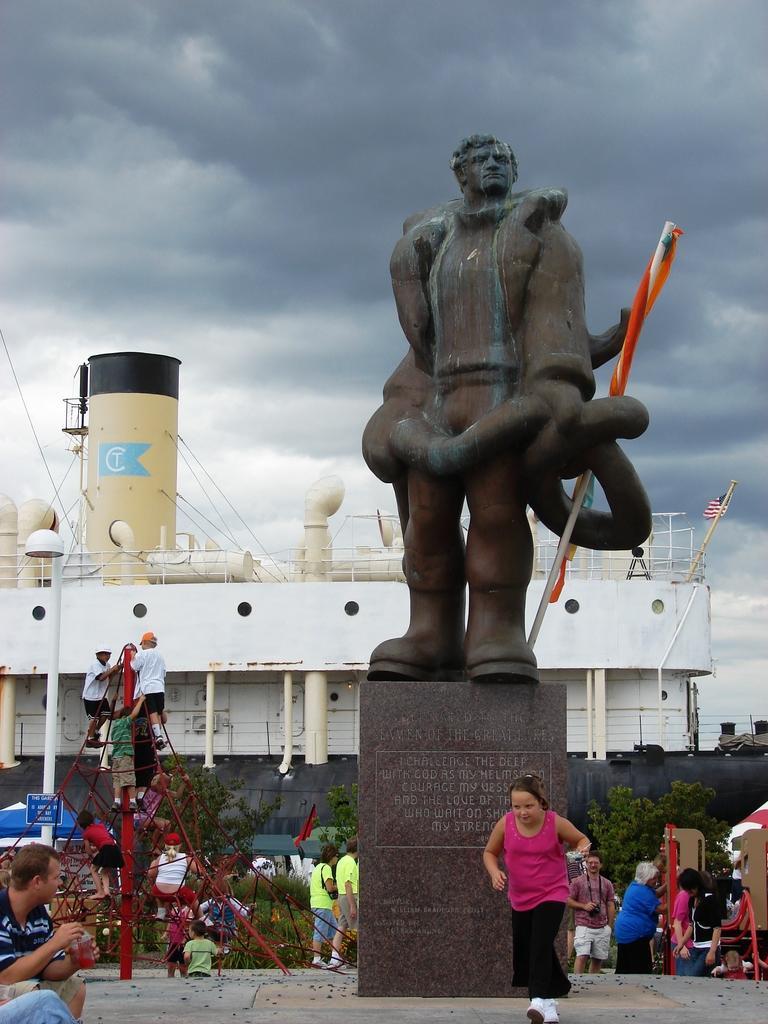Please provide a concise description of this image. In this image there is a statue in the middle. In the background there is a factory. At the top there is the sky with the black clouds. At the bottom there are few people who are playing by climbing the poles. In the background there are trees beside the wall. 